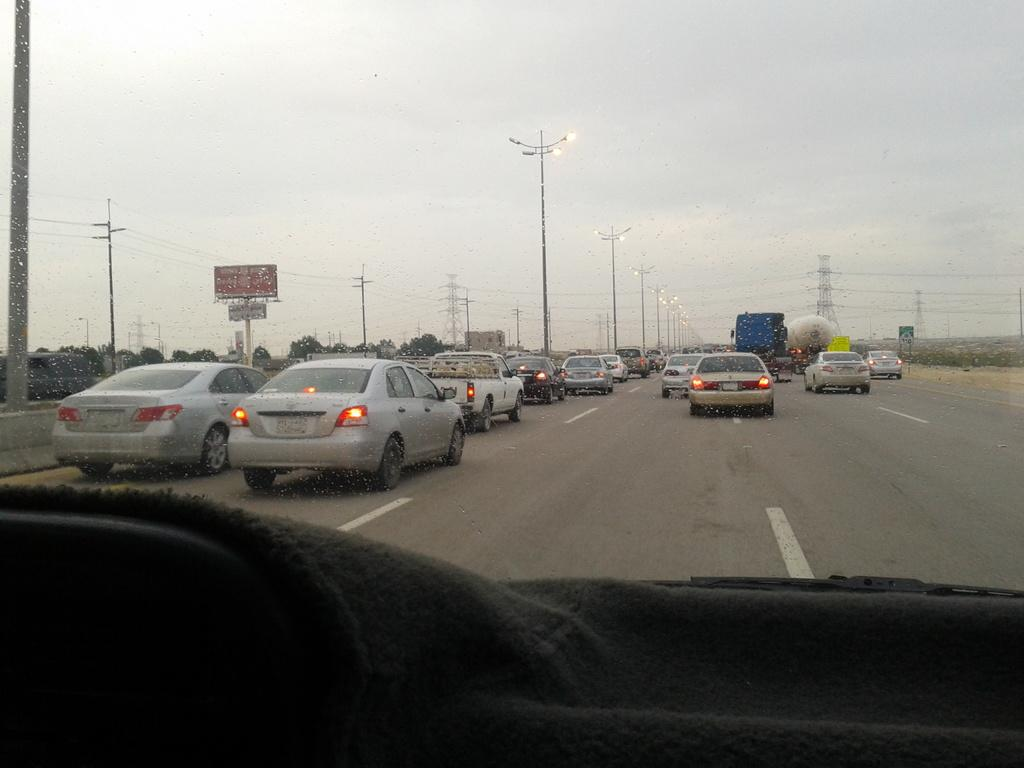What is the medium through which the image is taken? The image is taken through the glass of a vehicle. What can be seen on the road in the image? There are vehicles moving on the road in the image. What type of structures are visible in the image? There are poles and towers visible in the image. What type of vegetation is present in the image? There are trees in the image. What part of the natural environment is visible in the image? The sky is visible in the image. What type of scissors can be seen cutting the trees in the image? There are no scissors present in the image, and the trees are not being cut. How much money is visible in the image? There is no money visible in the image, such as a dime. 